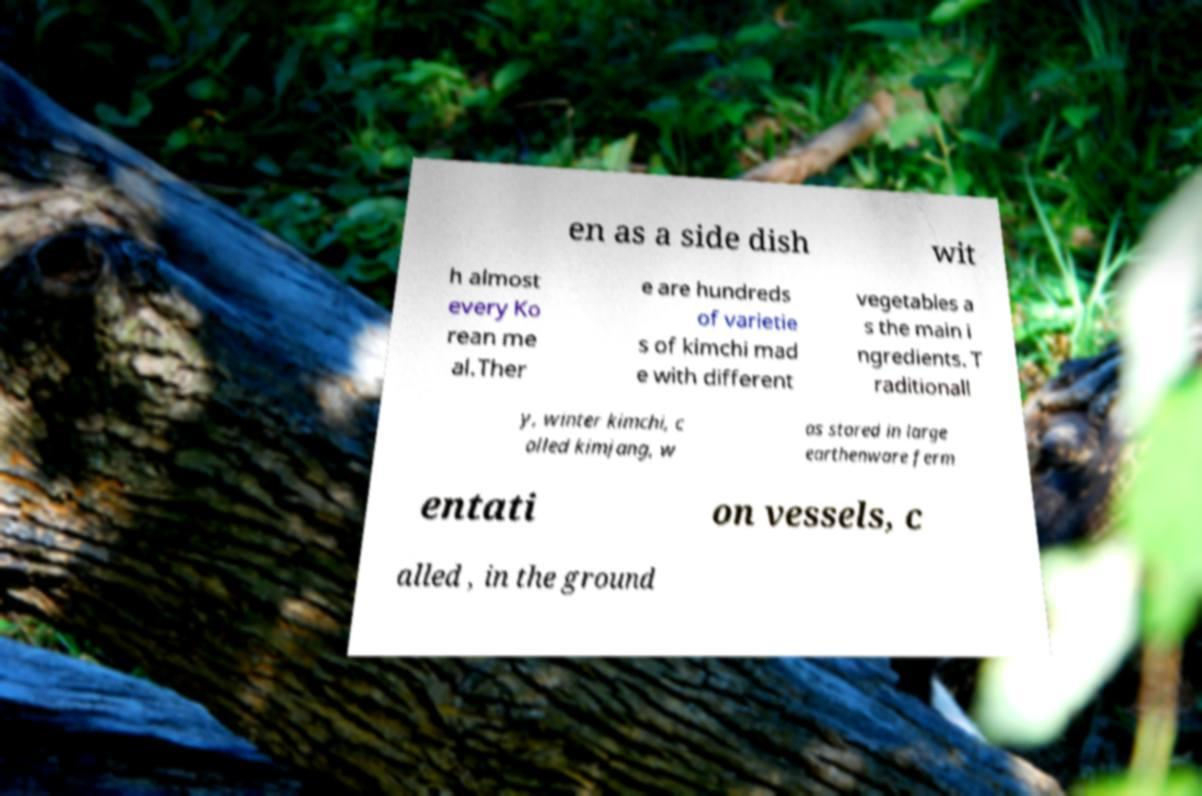There's text embedded in this image that I need extracted. Can you transcribe it verbatim? en as a side dish wit h almost every Ko rean me al.Ther e are hundreds of varietie s of kimchi mad e with different vegetables a s the main i ngredients. T raditionall y, winter kimchi, c alled kimjang, w as stored in large earthenware ferm entati on vessels, c alled , in the ground 